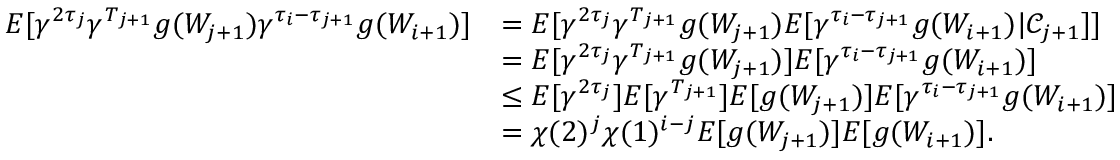<formula> <loc_0><loc_0><loc_500><loc_500>\begin{array} { r l } { E [ \gamma ^ { 2 \tau _ { j } } \gamma ^ { T _ { j + 1 } } g ( W _ { j + 1 } ) \gamma ^ { \tau _ { i } - \tau _ { j + 1 } } g ( W _ { i + 1 } ) ] } & { = E [ \gamma ^ { 2 \tau _ { j } } \gamma ^ { T _ { j + 1 } } g ( W _ { j + 1 } ) E [ \gamma ^ { \tau _ { i } - \tau _ { j + 1 } } g ( W _ { i + 1 } ) | \mathcal { C } _ { j + 1 } ] ] } \\ & { = E [ \gamma ^ { 2 \tau _ { j } } \gamma ^ { T _ { j + 1 } } g ( W _ { j + 1 } ) ] E [ \gamma ^ { \tau _ { i } - \tau _ { j + 1 } } g ( W _ { i + 1 } ) ] } \\ & { \leq E [ \gamma ^ { 2 \tau _ { j } } ] E [ \gamma ^ { T _ { j + 1 } } ] E [ g ( W _ { j + 1 } ) ] E [ \gamma ^ { \tau _ { i } - \tau _ { j + 1 } } g ( W _ { i + 1 } ) ] } \\ & { = \chi ( 2 ) ^ { j } \chi ( 1 ) ^ { i - j } E [ g ( W _ { j + 1 } ) ] E [ g ( W _ { i + 1 } ) ] . } \end{array}</formula> 